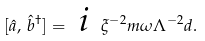<formula> <loc_0><loc_0><loc_500><loc_500>[ \hat { a } , \, \hat { b } ^ { \dag } ] = \emph { i } \, \xi ^ { - 2 } m \omega \Lambda ^ { - 2 } d .</formula> 